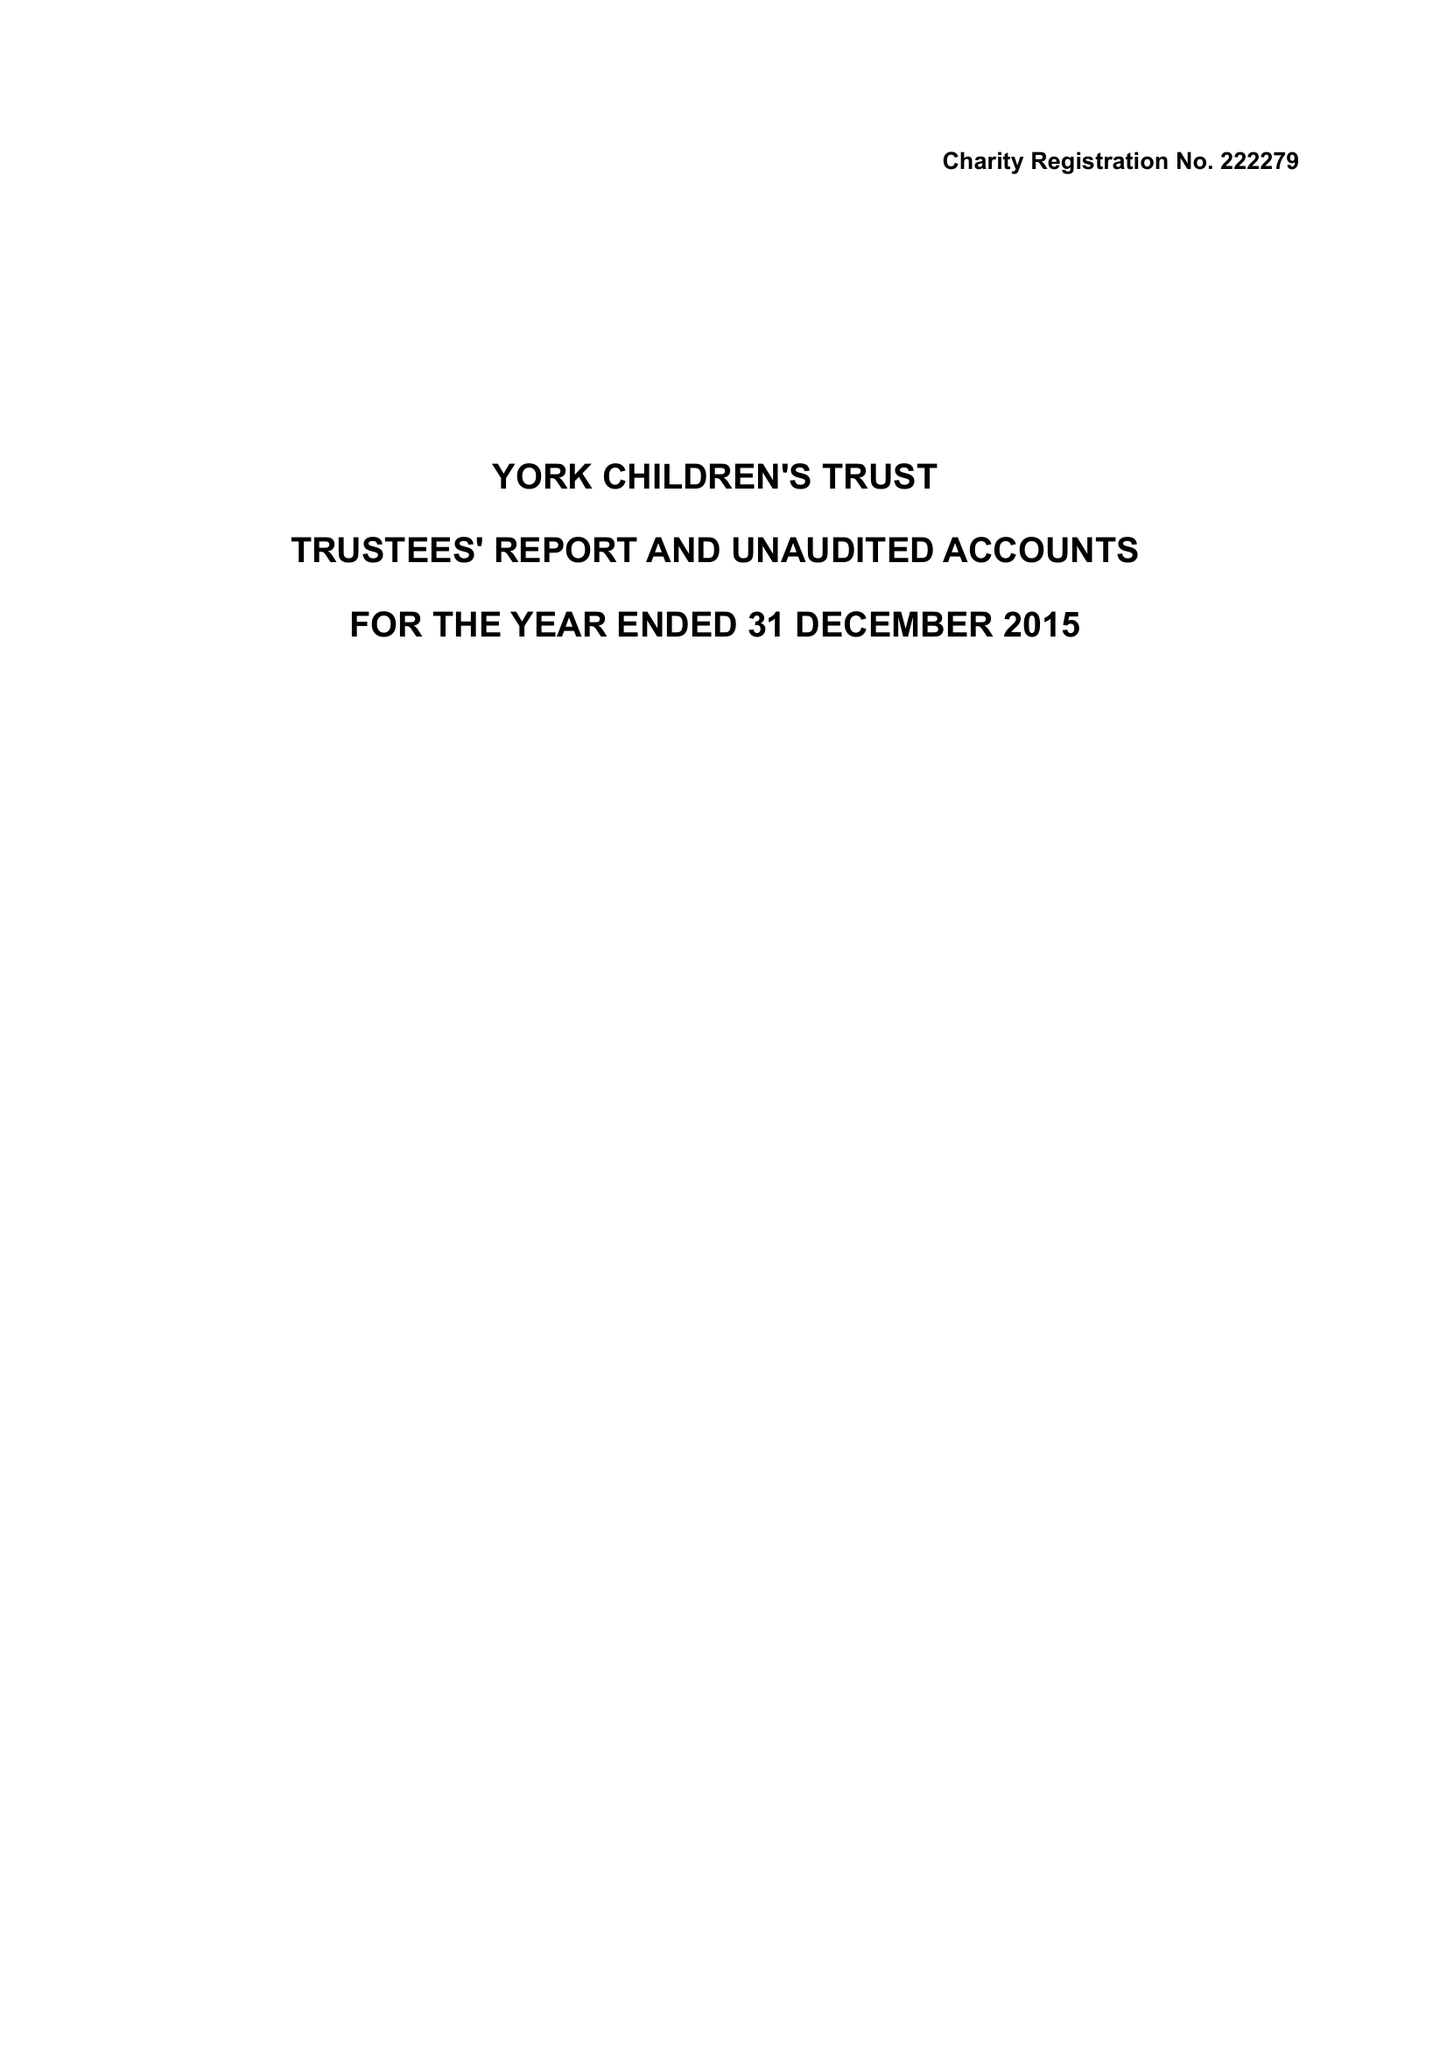What is the value for the income_annually_in_british_pounds?
Answer the question using a single word or phrase. 96093.00 